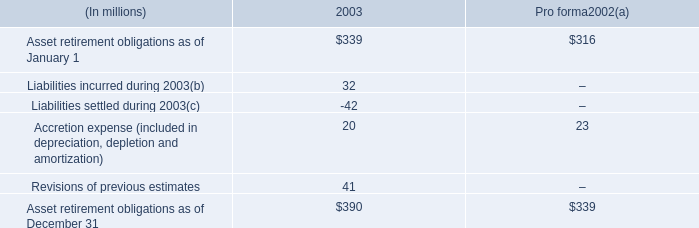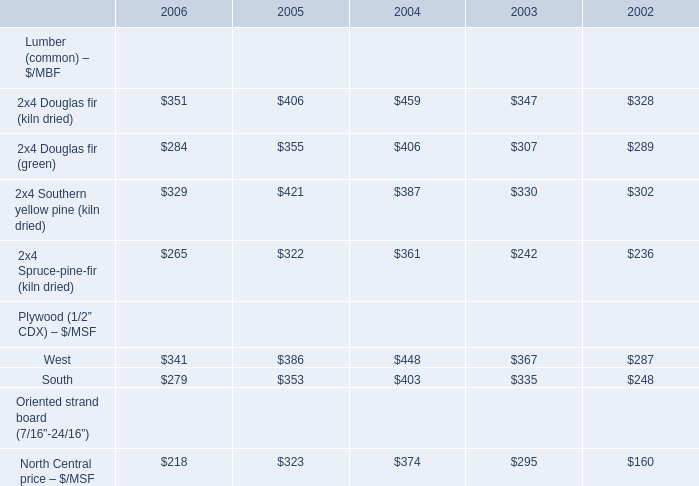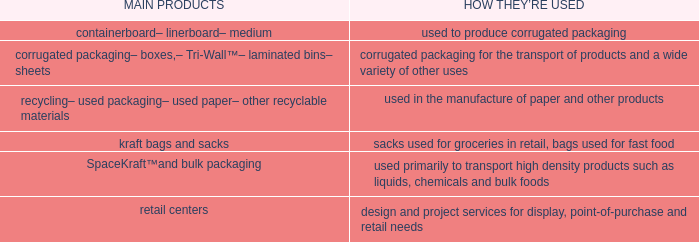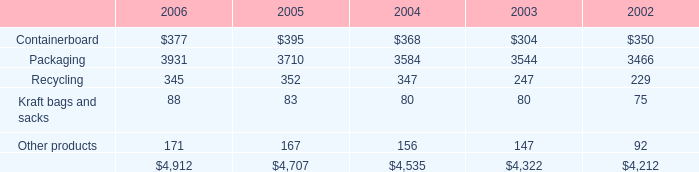What is the sum of Containerboard in 2006 and 2x4 Douglas fir (kiln dried) for Lumber (common) – $/MBF in 2005? 
Computations: (406 + 377)
Answer: 783.0. 